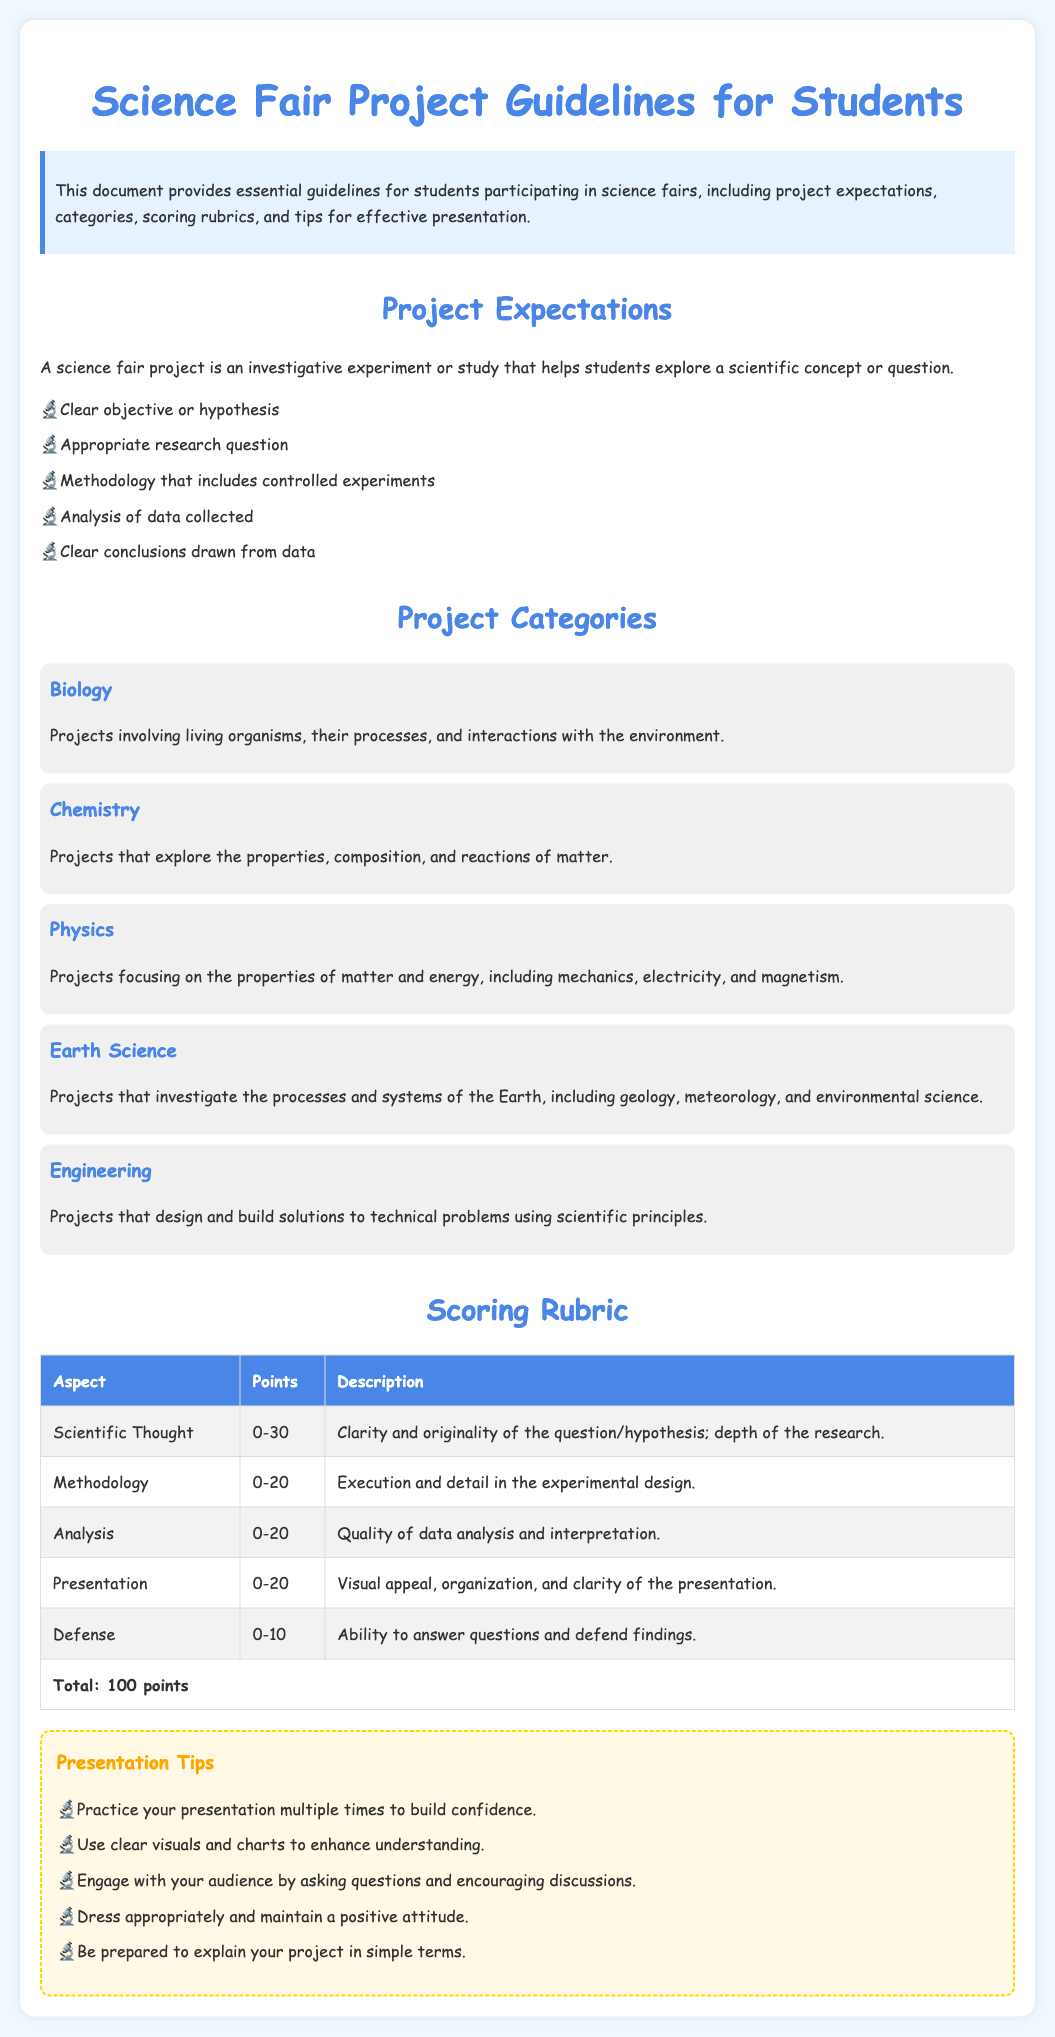What is a science fair project? A science fair project is an investigative experiment or study that helps students explore a scientific concept or question.
Answer: An investigative experiment or study What are the total points possible on the scoring rubric? The scoring rubric lists the aspects and their respective point ranges, adding up to a maximum score.
Answer: 100 points Which project category investigates living organisms? The document provides specific project categories with corresponding descriptions.
Answer: Biology How many points are allocated for the "Methodology" aspect in the scoring rubric? The scoring rubric specifies the points assigned to each aspect of the project evaluation.
Answer: 20 What should students do to enhance their presentation? The document includes tips on how to effectively present a science fair project.
Answer: Use clear visuals and charts What is the primary objective of having clear objectives or hypotheses? Importance is mentioned in the context of project expectations to indicate clarity and depth.
Answer: Clarity and originality Which aspect of the scoring rubric involves the ability to answer questions? Each aspect is detailed in the scoring rubric, relating to the defense of the project findings.
Answer: Defense What type of projects does the Engineering category focus on? The document defines the Engineering category to clarify its focus and expectations.
Answer: Design and build solutions 